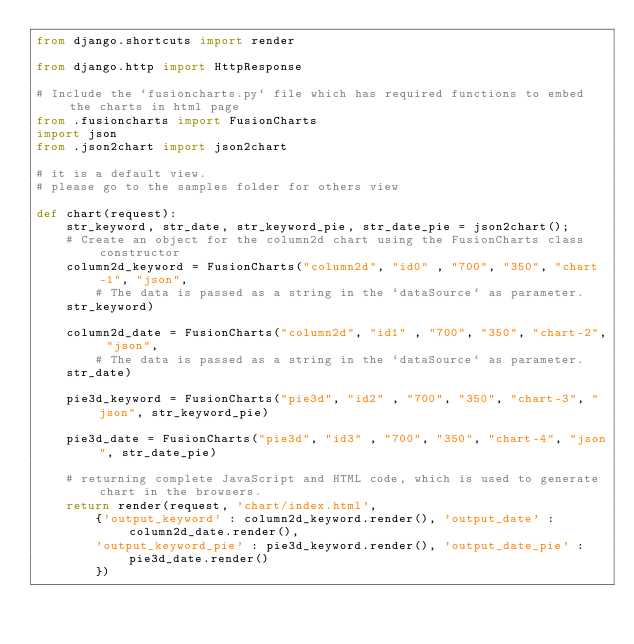Convert code to text. <code><loc_0><loc_0><loc_500><loc_500><_Python_>from django.shortcuts import render

from django.http import HttpResponse

# Include the `fusioncharts.py` file which has required functions to embed the charts in html page
from .fusioncharts import FusionCharts
import json
from .json2chart import json2chart

# it is a default view.
# please go to the samples folder for others view

def chart(request):
    str_keyword, str_date, str_keyword_pie, str_date_pie = json2chart();
    # Create an object for the column2d chart using the FusionCharts class constructor
    column2d_keyword = FusionCharts("column2d", "id0" , "700", "350", "chart-1", "json",
        # The data is passed as a string in the `dataSource` as parameter.
    str_keyword)

    column2d_date = FusionCharts("column2d", "id1" , "700", "350", "chart-2", "json",
        # The data is passed as a string in the `dataSource` as parameter.
    str_date)

    pie3d_keyword = FusionCharts("pie3d", "id2" , "700", "350", "chart-3", "json", str_keyword_pie)

    pie3d_date = FusionCharts("pie3d", "id3" , "700", "350", "chart-4", "json", str_date_pie)

    # returning complete JavaScript and HTML code, which is used to generate chart in the browsers.
    return render(request, 'chart/index.html',
        {'output_keyword' : column2d_keyword.render(), 'output_date' : column2d_date.render(),
        'output_keyword_pie' : pie3d_keyword.render(), 'output_date_pie' : pie3d_date.render()
        })
</code> 